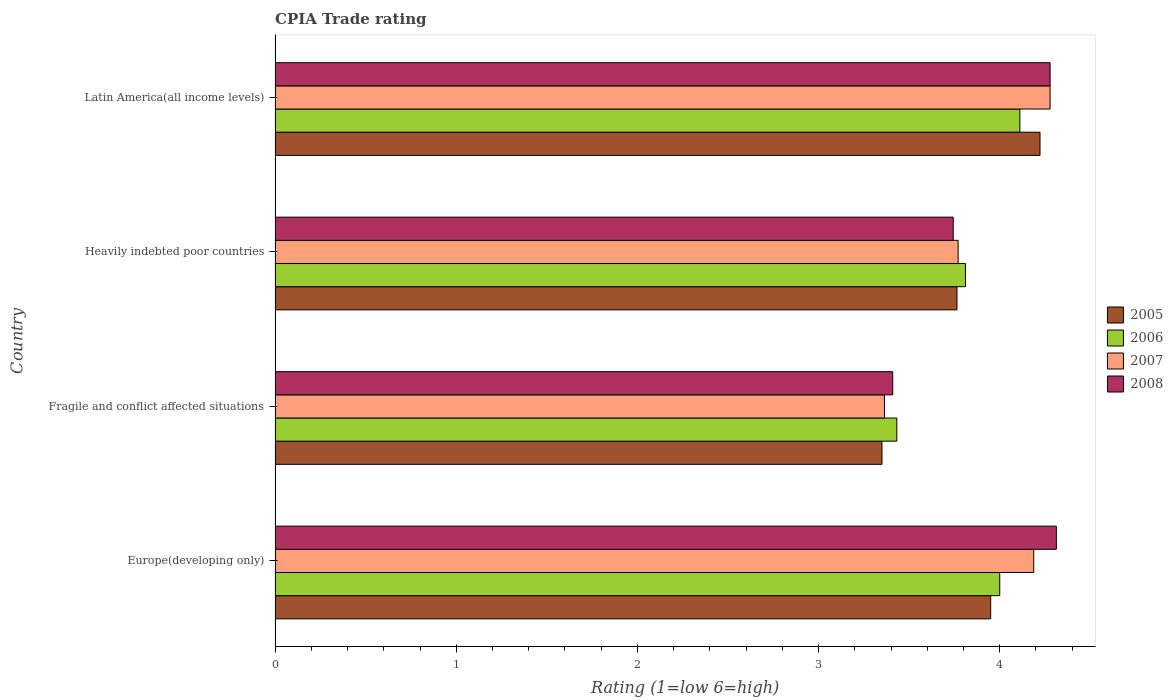How many groups of bars are there?
Give a very brief answer. 4. Are the number of bars per tick equal to the number of legend labels?
Ensure brevity in your answer.  Yes. How many bars are there on the 1st tick from the top?
Give a very brief answer. 4. What is the label of the 2nd group of bars from the top?
Offer a very short reply. Heavily indebted poor countries. What is the CPIA rating in 2007 in Europe(developing only)?
Make the answer very short. 4.19. Across all countries, what is the maximum CPIA rating in 2007?
Make the answer very short. 4.28. Across all countries, what is the minimum CPIA rating in 2006?
Your response must be concise. 3.43. In which country was the CPIA rating in 2005 maximum?
Make the answer very short. Latin America(all income levels). In which country was the CPIA rating in 2008 minimum?
Your answer should be compact. Fragile and conflict affected situations. What is the total CPIA rating in 2008 in the graph?
Keep it short and to the point. 15.74. What is the difference between the CPIA rating in 2006 in Fragile and conflict affected situations and that in Latin America(all income levels)?
Give a very brief answer. -0.68. What is the difference between the CPIA rating in 2005 in Heavily indebted poor countries and the CPIA rating in 2006 in Europe(developing only)?
Provide a succinct answer. -0.24. What is the average CPIA rating in 2008 per country?
Your answer should be very brief. 3.94. What is the difference between the CPIA rating in 2006 and CPIA rating in 2008 in Heavily indebted poor countries?
Your answer should be compact. 0.07. What is the ratio of the CPIA rating in 2006 in Europe(developing only) to that in Heavily indebted poor countries?
Provide a short and direct response. 1.05. What is the difference between the highest and the second highest CPIA rating in 2007?
Offer a very short reply. 0.09. What is the difference between the highest and the lowest CPIA rating in 2006?
Ensure brevity in your answer.  0.68. Is the sum of the CPIA rating in 2007 in Fragile and conflict affected situations and Heavily indebted poor countries greater than the maximum CPIA rating in 2006 across all countries?
Give a very brief answer. Yes. Is it the case that in every country, the sum of the CPIA rating in 2008 and CPIA rating in 2005 is greater than the sum of CPIA rating in 2006 and CPIA rating in 2007?
Provide a succinct answer. No. What does the 3rd bar from the top in Europe(developing only) represents?
Your answer should be very brief. 2006. Are all the bars in the graph horizontal?
Provide a succinct answer. Yes. What is the difference between two consecutive major ticks on the X-axis?
Provide a short and direct response. 1. Are the values on the major ticks of X-axis written in scientific E-notation?
Offer a very short reply. No. Where does the legend appear in the graph?
Make the answer very short. Center right. How many legend labels are there?
Your response must be concise. 4. How are the legend labels stacked?
Offer a terse response. Vertical. What is the title of the graph?
Offer a very short reply. CPIA Trade rating. Does "1968" appear as one of the legend labels in the graph?
Your answer should be very brief. No. What is the Rating (1=low 6=high) of 2005 in Europe(developing only)?
Provide a short and direct response. 3.95. What is the Rating (1=low 6=high) in 2006 in Europe(developing only)?
Provide a short and direct response. 4. What is the Rating (1=low 6=high) of 2007 in Europe(developing only)?
Offer a very short reply. 4.19. What is the Rating (1=low 6=high) in 2008 in Europe(developing only)?
Provide a succinct answer. 4.31. What is the Rating (1=low 6=high) in 2005 in Fragile and conflict affected situations?
Offer a very short reply. 3.35. What is the Rating (1=low 6=high) of 2006 in Fragile and conflict affected situations?
Ensure brevity in your answer.  3.43. What is the Rating (1=low 6=high) of 2007 in Fragile and conflict affected situations?
Make the answer very short. 3.36. What is the Rating (1=low 6=high) in 2008 in Fragile and conflict affected situations?
Make the answer very short. 3.41. What is the Rating (1=low 6=high) in 2005 in Heavily indebted poor countries?
Give a very brief answer. 3.76. What is the Rating (1=low 6=high) of 2006 in Heavily indebted poor countries?
Ensure brevity in your answer.  3.81. What is the Rating (1=low 6=high) of 2007 in Heavily indebted poor countries?
Give a very brief answer. 3.77. What is the Rating (1=low 6=high) of 2008 in Heavily indebted poor countries?
Keep it short and to the point. 3.74. What is the Rating (1=low 6=high) of 2005 in Latin America(all income levels)?
Provide a short and direct response. 4.22. What is the Rating (1=low 6=high) in 2006 in Latin America(all income levels)?
Ensure brevity in your answer.  4.11. What is the Rating (1=low 6=high) of 2007 in Latin America(all income levels)?
Give a very brief answer. 4.28. What is the Rating (1=low 6=high) of 2008 in Latin America(all income levels)?
Your answer should be compact. 4.28. Across all countries, what is the maximum Rating (1=low 6=high) of 2005?
Your answer should be very brief. 4.22. Across all countries, what is the maximum Rating (1=low 6=high) in 2006?
Provide a short and direct response. 4.11. Across all countries, what is the maximum Rating (1=low 6=high) of 2007?
Make the answer very short. 4.28. Across all countries, what is the maximum Rating (1=low 6=high) of 2008?
Offer a terse response. 4.31. Across all countries, what is the minimum Rating (1=low 6=high) of 2005?
Your answer should be compact. 3.35. Across all countries, what is the minimum Rating (1=low 6=high) of 2006?
Your answer should be very brief. 3.43. Across all countries, what is the minimum Rating (1=low 6=high) of 2007?
Offer a very short reply. 3.36. Across all countries, what is the minimum Rating (1=low 6=high) of 2008?
Offer a very short reply. 3.41. What is the total Rating (1=low 6=high) of 2005 in the graph?
Your answer should be very brief. 15.29. What is the total Rating (1=low 6=high) of 2006 in the graph?
Ensure brevity in your answer.  15.35. What is the total Rating (1=low 6=high) in 2007 in the graph?
Your response must be concise. 15.6. What is the total Rating (1=low 6=high) of 2008 in the graph?
Offer a terse response. 15.74. What is the difference between the Rating (1=low 6=high) of 2006 in Europe(developing only) and that in Fragile and conflict affected situations?
Your answer should be compact. 0.57. What is the difference between the Rating (1=low 6=high) in 2007 in Europe(developing only) and that in Fragile and conflict affected situations?
Your answer should be very brief. 0.82. What is the difference between the Rating (1=low 6=high) in 2008 in Europe(developing only) and that in Fragile and conflict affected situations?
Make the answer very short. 0.9. What is the difference between the Rating (1=low 6=high) of 2005 in Europe(developing only) and that in Heavily indebted poor countries?
Keep it short and to the point. 0.19. What is the difference between the Rating (1=low 6=high) in 2006 in Europe(developing only) and that in Heavily indebted poor countries?
Your answer should be compact. 0.19. What is the difference between the Rating (1=low 6=high) in 2007 in Europe(developing only) and that in Heavily indebted poor countries?
Offer a terse response. 0.42. What is the difference between the Rating (1=low 6=high) in 2008 in Europe(developing only) and that in Heavily indebted poor countries?
Your response must be concise. 0.57. What is the difference between the Rating (1=low 6=high) in 2005 in Europe(developing only) and that in Latin America(all income levels)?
Offer a terse response. -0.27. What is the difference between the Rating (1=low 6=high) in 2006 in Europe(developing only) and that in Latin America(all income levels)?
Ensure brevity in your answer.  -0.11. What is the difference between the Rating (1=low 6=high) in 2007 in Europe(developing only) and that in Latin America(all income levels)?
Keep it short and to the point. -0.09. What is the difference between the Rating (1=low 6=high) in 2008 in Europe(developing only) and that in Latin America(all income levels)?
Your answer should be very brief. 0.03. What is the difference between the Rating (1=low 6=high) in 2005 in Fragile and conflict affected situations and that in Heavily indebted poor countries?
Your response must be concise. -0.41. What is the difference between the Rating (1=low 6=high) of 2006 in Fragile and conflict affected situations and that in Heavily indebted poor countries?
Keep it short and to the point. -0.38. What is the difference between the Rating (1=low 6=high) in 2007 in Fragile and conflict affected situations and that in Heavily indebted poor countries?
Your response must be concise. -0.41. What is the difference between the Rating (1=low 6=high) of 2008 in Fragile and conflict affected situations and that in Heavily indebted poor countries?
Ensure brevity in your answer.  -0.33. What is the difference between the Rating (1=low 6=high) in 2005 in Fragile and conflict affected situations and that in Latin America(all income levels)?
Provide a succinct answer. -0.87. What is the difference between the Rating (1=low 6=high) in 2006 in Fragile and conflict affected situations and that in Latin America(all income levels)?
Give a very brief answer. -0.68. What is the difference between the Rating (1=low 6=high) in 2007 in Fragile and conflict affected situations and that in Latin America(all income levels)?
Offer a very short reply. -0.91. What is the difference between the Rating (1=low 6=high) in 2008 in Fragile and conflict affected situations and that in Latin America(all income levels)?
Ensure brevity in your answer.  -0.87. What is the difference between the Rating (1=low 6=high) of 2005 in Heavily indebted poor countries and that in Latin America(all income levels)?
Your response must be concise. -0.46. What is the difference between the Rating (1=low 6=high) of 2006 in Heavily indebted poor countries and that in Latin America(all income levels)?
Offer a very short reply. -0.3. What is the difference between the Rating (1=low 6=high) of 2007 in Heavily indebted poor countries and that in Latin America(all income levels)?
Give a very brief answer. -0.51. What is the difference between the Rating (1=low 6=high) of 2008 in Heavily indebted poor countries and that in Latin America(all income levels)?
Offer a very short reply. -0.53. What is the difference between the Rating (1=low 6=high) of 2005 in Europe(developing only) and the Rating (1=low 6=high) of 2006 in Fragile and conflict affected situations?
Your response must be concise. 0.52. What is the difference between the Rating (1=low 6=high) in 2005 in Europe(developing only) and the Rating (1=low 6=high) in 2007 in Fragile and conflict affected situations?
Provide a succinct answer. 0.59. What is the difference between the Rating (1=low 6=high) of 2005 in Europe(developing only) and the Rating (1=low 6=high) of 2008 in Fragile and conflict affected situations?
Your answer should be very brief. 0.54. What is the difference between the Rating (1=low 6=high) in 2006 in Europe(developing only) and the Rating (1=low 6=high) in 2007 in Fragile and conflict affected situations?
Ensure brevity in your answer.  0.64. What is the difference between the Rating (1=low 6=high) of 2006 in Europe(developing only) and the Rating (1=low 6=high) of 2008 in Fragile and conflict affected situations?
Provide a succinct answer. 0.59. What is the difference between the Rating (1=low 6=high) in 2007 in Europe(developing only) and the Rating (1=low 6=high) in 2008 in Fragile and conflict affected situations?
Your answer should be compact. 0.78. What is the difference between the Rating (1=low 6=high) of 2005 in Europe(developing only) and the Rating (1=low 6=high) of 2006 in Heavily indebted poor countries?
Your response must be concise. 0.14. What is the difference between the Rating (1=low 6=high) in 2005 in Europe(developing only) and the Rating (1=low 6=high) in 2007 in Heavily indebted poor countries?
Provide a succinct answer. 0.18. What is the difference between the Rating (1=low 6=high) in 2005 in Europe(developing only) and the Rating (1=low 6=high) in 2008 in Heavily indebted poor countries?
Offer a very short reply. 0.21. What is the difference between the Rating (1=low 6=high) in 2006 in Europe(developing only) and the Rating (1=low 6=high) in 2007 in Heavily indebted poor countries?
Ensure brevity in your answer.  0.23. What is the difference between the Rating (1=low 6=high) in 2006 in Europe(developing only) and the Rating (1=low 6=high) in 2008 in Heavily indebted poor countries?
Keep it short and to the point. 0.26. What is the difference between the Rating (1=low 6=high) of 2007 in Europe(developing only) and the Rating (1=low 6=high) of 2008 in Heavily indebted poor countries?
Offer a very short reply. 0.44. What is the difference between the Rating (1=low 6=high) in 2005 in Europe(developing only) and the Rating (1=low 6=high) in 2006 in Latin America(all income levels)?
Your answer should be very brief. -0.16. What is the difference between the Rating (1=low 6=high) of 2005 in Europe(developing only) and the Rating (1=low 6=high) of 2007 in Latin America(all income levels)?
Offer a very short reply. -0.33. What is the difference between the Rating (1=low 6=high) in 2005 in Europe(developing only) and the Rating (1=low 6=high) in 2008 in Latin America(all income levels)?
Offer a very short reply. -0.33. What is the difference between the Rating (1=low 6=high) of 2006 in Europe(developing only) and the Rating (1=low 6=high) of 2007 in Latin America(all income levels)?
Offer a terse response. -0.28. What is the difference between the Rating (1=low 6=high) in 2006 in Europe(developing only) and the Rating (1=low 6=high) in 2008 in Latin America(all income levels)?
Ensure brevity in your answer.  -0.28. What is the difference between the Rating (1=low 6=high) of 2007 in Europe(developing only) and the Rating (1=low 6=high) of 2008 in Latin America(all income levels)?
Keep it short and to the point. -0.09. What is the difference between the Rating (1=low 6=high) of 2005 in Fragile and conflict affected situations and the Rating (1=low 6=high) of 2006 in Heavily indebted poor countries?
Provide a short and direct response. -0.46. What is the difference between the Rating (1=low 6=high) in 2005 in Fragile and conflict affected situations and the Rating (1=low 6=high) in 2007 in Heavily indebted poor countries?
Keep it short and to the point. -0.42. What is the difference between the Rating (1=low 6=high) in 2005 in Fragile and conflict affected situations and the Rating (1=low 6=high) in 2008 in Heavily indebted poor countries?
Keep it short and to the point. -0.39. What is the difference between the Rating (1=low 6=high) of 2006 in Fragile and conflict affected situations and the Rating (1=low 6=high) of 2007 in Heavily indebted poor countries?
Make the answer very short. -0.34. What is the difference between the Rating (1=low 6=high) of 2006 in Fragile and conflict affected situations and the Rating (1=low 6=high) of 2008 in Heavily indebted poor countries?
Offer a terse response. -0.31. What is the difference between the Rating (1=low 6=high) of 2007 in Fragile and conflict affected situations and the Rating (1=low 6=high) of 2008 in Heavily indebted poor countries?
Ensure brevity in your answer.  -0.38. What is the difference between the Rating (1=low 6=high) in 2005 in Fragile and conflict affected situations and the Rating (1=low 6=high) in 2006 in Latin America(all income levels)?
Offer a very short reply. -0.76. What is the difference between the Rating (1=low 6=high) in 2005 in Fragile and conflict affected situations and the Rating (1=low 6=high) in 2007 in Latin America(all income levels)?
Provide a short and direct response. -0.93. What is the difference between the Rating (1=low 6=high) in 2005 in Fragile and conflict affected situations and the Rating (1=low 6=high) in 2008 in Latin America(all income levels)?
Make the answer very short. -0.93. What is the difference between the Rating (1=low 6=high) in 2006 in Fragile and conflict affected situations and the Rating (1=low 6=high) in 2007 in Latin America(all income levels)?
Your response must be concise. -0.85. What is the difference between the Rating (1=low 6=high) of 2006 in Fragile and conflict affected situations and the Rating (1=low 6=high) of 2008 in Latin America(all income levels)?
Ensure brevity in your answer.  -0.85. What is the difference between the Rating (1=low 6=high) of 2007 in Fragile and conflict affected situations and the Rating (1=low 6=high) of 2008 in Latin America(all income levels)?
Offer a very short reply. -0.91. What is the difference between the Rating (1=low 6=high) of 2005 in Heavily indebted poor countries and the Rating (1=low 6=high) of 2006 in Latin America(all income levels)?
Give a very brief answer. -0.35. What is the difference between the Rating (1=low 6=high) of 2005 in Heavily indebted poor countries and the Rating (1=low 6=high) of 2007 in Latin America(all income levels)?
Keep it short and to the point. -0.51. What is the difference between the Rating (1=low 6=high) in 2005 in Heavily indebted poor countries and the Rating (1=low 6=high) in 2008 in Latin America(all income levels)?
Make the answer very short. -0.51. What is the difference between the Rating (1=low 6=high) in 2006 in Heavily indebted poor countries and the Rating (1=low 6=high) in 2007 in Latin America(all income levels)?
Ensure brevity in your answer.  -0.47. What is the difference between the Rating (1=low 6=high) of 2006 in Heavily indebted poor countries and the Rating (1=low 6=high) of 2008 in Latin America(all income levels)?
Your answer should be compact. -0.47. What is the difference between the Rating (1=low 6=high) of 2007 in Heavily indebted poor countries and the Rating (1=low 6=high) of 2008 in Latin America(all income levels)?
Keep it short and to the point. -0.51. What is the average Rating (1=low 6=high) in 2005 per country?
Your response must be concise. 3.82. What is the average Rating (1=low 6=high) of 2006 per country?
Make the answer very short. 3.84. What is the average Rating (1=low 6=high) in 2007 per country?
Your response must be concise. 3.9. What is the average Rating (1=low 6=high) of 2008 per country?
Provide a succinct answer. 3.94. What is the difference between the Rating (1=low 6=high) in 2005 and Rating (1=low 6=high) in 2006 in Europe(developing only)?
Offer a very short reply. -0.05. What is the difference between the Rating (1=low 6=high) of 2005 and Rating (1=low 6=high) of 2007 in Europe(developing only)?
Your answer should be compact. -0.24. What is the difference between the Rating (1=low 6=high) in 2005 and Rating (1=low 6=high) in 2008 in Europe(developing only)?
Provide a succinct answer. -0.36. What is the difference between the Rating (1=low 6=high) of 2006 and Rating (1=low 6=high) of 2007 in Europe(developing only)?
Your response must be concise. -0.19. What is the difference between the Rating (1=low 6=high) of 2006 and Rating (1=low 6=high) of 2008 in Europe(developing only)?
Your response must be concise. -0.31. What is the difference between the Rating (1=low 6=high) in 2007 and Rating (1=low 6=high) in 2008 in Europe(developing only)?
Offer a very short reply. -0.12. What is the difference between the Rating (1=low 6=high) in 2005 and Rating (1=low 6=high) in 2006 in Fragile and conflict affected situations?
Your answer should be compact. -0.08. What is the difference between the Rating (1=low 6=high) of 2005 and Rating (1=low 6=high) of 2007 in Fragile and conflict affected situations?
Ensure brevity in your answer.  -0.01. What is the difference between the Rating (1=low 6=high) in 2005 and Rating (1=low 6=high) in 2008 in Fragile and conflict affected situations?
Keep it short and to the point. -0.06. What is the difference between the Rating (1=low 6=high) of 2006 and Rating (1=low 6=high) of 2007 in Fragile and conflict affected situations?
Give a very brief answer. 0.07. What is the difference between the Rating (1=low 6=high) in 2006 and Rating (1=low 6=high) in 2008 in Fragile and conflict affected situations?
Your answer should be very brief. 0.02. What is the difference between the Rating (1=low 6=high) of 2007 and Rating (1=low 6=high) of 2008 in Fragile and conflict affected situations?
Provide a short and direct response. -0.05. What is the difference between the Rating (1=low 6=high) of 2005 and Rating (1=low 6=high) of 2006 in Heavily indebted poor countries?
Your response must be concise. -0.05. What is the difference between the Rating (1=low 6=high) in 2005 and Rating (1=low 6=high) in 2007 in Heavily indebted poor countries?
Make the answer very short. -0.01. What is the difference between the Rating (1=low 6=high) in 2005 and Rating (1=low 6=high) in 2008 in Heavily indebted poor countries?
Your answer should be very brief. 0.02. What is the difference between the Rating (1=low 6=high) of 2006 and Rating (1=low 6=high) of 2007 in Heavily indebted poor countries?
Offer a very short reply. 0.04. What is the difference between the Rating (1=low 6=high) of 2006 and Rating (1=low 6=high) of 2008 in Heavily indebted poor countries?
Provide a succinct answer. 0.07. What is the difference between the Rating (1=low 6=high) of 2007 and Rating (1=low 6=high) of 2008 in Heavily indebted poor countries?
Your response must be concise. 0.03. What is the difference between the Rating (1=low 6=high) of 2005 and Rating (1=low 6=high) of 2007 in Latin America(all income levels)?
Make the answer very short. -0.06. What is the difference between the Rating (1=low 6=high) of 2005 and Rating (1=low 6=high) of 2008 in Latin America(all income levels)?
Your answer should be very brief. -0.06. What is the ratio of the Rating (1=low 6=high) of 2005 in Europe(developing only) to that in Fragile and conflict affected situations?
Offer a very short reply. 1.18. What is the ratio of the Rating (1=low 6=high) of 2006 in Europe(developing only) to that in Fragile and conflict affected situations?
Ensure brevity in your answer.  1.17. What is the ratio of the Rating (1=low 6=high) in 2007 in Europe(developing only) to that in Fragile and conflict affected situations?
Give a very brief answer. 1.24. What is the ratio of the Rating (1=low 6=high) of 2008 in Europe(developing only) to that in Fragile and conflict affected situations?
Offer a terse response. 1.26. What is the ratio of the Rating (1=low 6=high) in 2005 in Europe(developing only) to that in Heavily indebted poor countries?
Ensure brevity in your answer.  1.05. What is the ratio of the Rating (1=low 6=high) of 2006 in Europe(developing only) to that in Heavily indebted poor countries?
Keep it short and to the point. 1.05. What is the ratio of the Rating (1=low 6=high) in 2007 in Europe(developing only) to that in Heavily indebted poor countries?
Your answer should be very brief. 1.11. What is the ratio of the Rating (1=low 6=high) in 2008 in Europe(developing only) to that in Heavily indebted poor countries?
Give a very brief answer. 1.15. What is the ratio of the Rating (1=low 6=high) in 2005 in Europe(developing only) to that in Latin America(all income levels)?
Your response must be concise. 0.94. What is the ratio of the Rating (1=low 6=high) in 2007 in Europe(developing only) to that in Latin America(all income levels)?
Your answer should be very brief. 0.98. What is the ratio of the Rating (1=low 6=high) of 2005 in Fragile and conflict affected situations to that in Heavily indebted poor countries?
Keep it short and to the point. 0.89. What is the ratio of the Rating (1=low 6=high) in 2006 in Fragile and conflict affected situations to that in Heavily indebted poor countries?
Give a very brief answer. 0.9. What is the ratio of the Rating (1=low 6=high) in 2007 in Fragile and conflict affected situations to that in Heavily indebted poor countries?
Your answer should be compact. 0.89. What is the ratio of the Rating (1=low 6=high) in 2008 in Fragile and conflict affected situations to that in Heavily indebted poor countries?
Ensure brevity in your answer.  0.91. What is the ratio of the Rating (1=low 6=high) of 2005 in Fragile and conflict affected situations to that in Latin America(all income levels)?
Provide a succinct answer. 0.79. What is the ratio of the Rating (1=low 6=high) in 2006 in Fragile and conflict affected situations to that in Latin America(all income levels)?
Make the answer very short. 0.83. What is the ratio of the Rating (1=low 6=high) of 2007 in Fragile and conflict affected situations to that in Latin America(all income levels)?
Your answer should be compact. 0.79. What is the ratio of the Rating (1=low 6=high) of 2008 in Fragile and conflict affected situations to that in Latin America(all income levels)?
Keep it short and to the point. 0.8. What is the ratio of the Rating (1=low 6=high) of 2005 in Heavily indebted poor countries to that in Latin America(all income levels)?
Give a very brief answer. 0.89. What is the ratio of the Rating (1=low 6=high) in 2006 in Heavily indebted poor countries to that in Latin America(all income levels)?
Keep it short and to the point. 0.93. What is the ratio of the Rating (1=low 6=high) in 2007 in Heavily indebted poor countries to that in Latin America(all income levels)?
Your answer should be compact. 0.88. What is the difference between the highest and the second highest Rating (1=low 6=high) of 2005?
Ensure brevity in your answer.  0.27. What is the difference between the highest and the second highest Rating (1=low 6=high) of 2006?
Ensure brevity in your answer.  0.11. What is the difference between the highest and the second highest Rating (1=low 6=high) of 2007?
Offer a terse response. 0.09. What is the difference between the highest and the second highest Rating (1=low 6=high) in 2008?
Your response must be concise. 0.03. What is the difference between the highest and the lowest Rating (1=low 6=high) in 2005?
Make the answer very short. 0.87. What is the difference between the highest and the lowest Rating (1=low 6=high) in 2006?
Offer a very short reply. 0.68. What is the difference between the highest and the lowest Rating (1=low 6=high) in 2007?
Provide a succinct answer. 0.91. What is the difference between the highest and the lowest Rating (1=low 6=high) of 2008?
Keep it short and to the point. 0.9. 